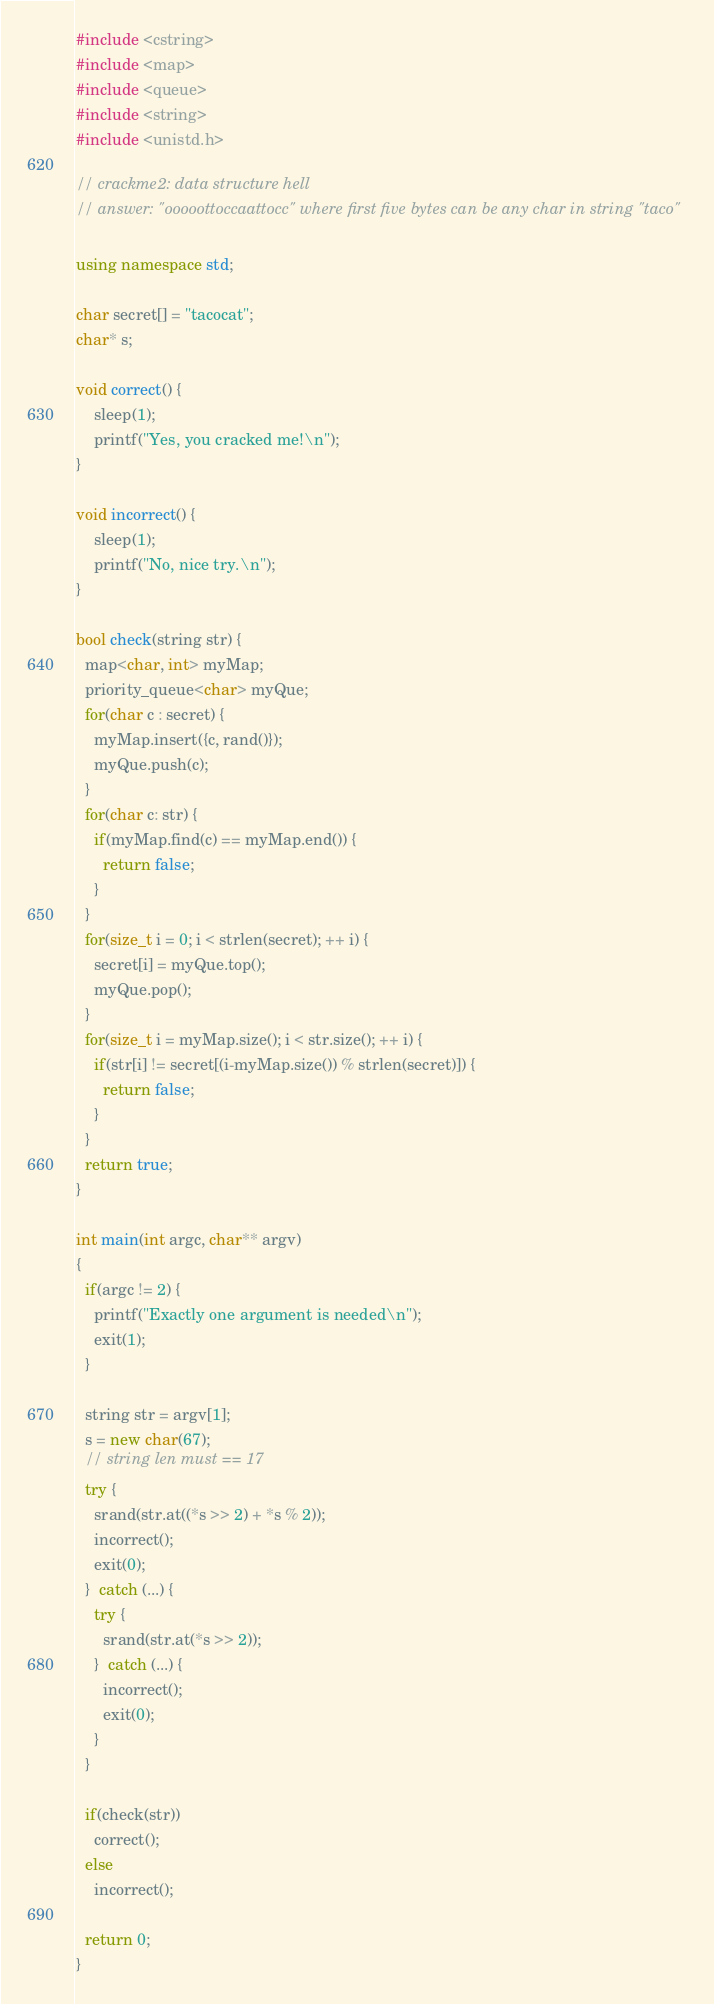<code> <loc_0><loc_0><loc_500><loc_500><_C++_>#include <cstring>
#include <map>
#include <queue>
#include <string>
#include <unistd.h>

// crackme2: data structure hell
// answer: "ooooottoccaattocc" where first five bytes can be any char in string "taco"

using namespace std;

char secret[] = "tacocat";
char* s;

void correct() {
    sleep(1);
    printf("Yes, you cracked me!\n");
}

void incorrect() {
    sleep(1);
    printf("No, nice try.\n");
}

bool check(string str) {
  map<char, int> myMap;
  priority_queue<char> myQue;
  for(char c : secret) {
    myMap.insert({c, rand()});
    myQue.push(c);
  }
  for(char c: str) {
    if(myMap.find(c) == myMap.end()) {
      return false;
    }
  }
  for(size_t i = 0; i < strlen(secret); ++ i) {
    secret[i] = myQue.top();
    myQue.pop();
  }
  for(size_t i = myMap.size(); i < str.size(); ++ i) {
    if(str[i] != secret[(i-myMap.size()) % strlen(secret)]) {
      return false;
    }
  }
  return true;
}

int main(int argc, char** argv)
{
  if(argc != 2) {
    printf("Exactly one argument is needed\n");
    exit(1);
  }

  string str = argv[1];
  s = new char(67);
  // string len must == 17
  try {
    srand(str.at((*s >> 2) + *s % 2));
    incorrect();
    exit(0);
  }  catch (...) {
    try {
      srand(str.at(*s >> 2));
    }  catch (...) {
      incorrect();
      exit(0);
    }
  }

  if(check(str))
    correct();
  else
    incorrect();

  return 0;
}
</code> 